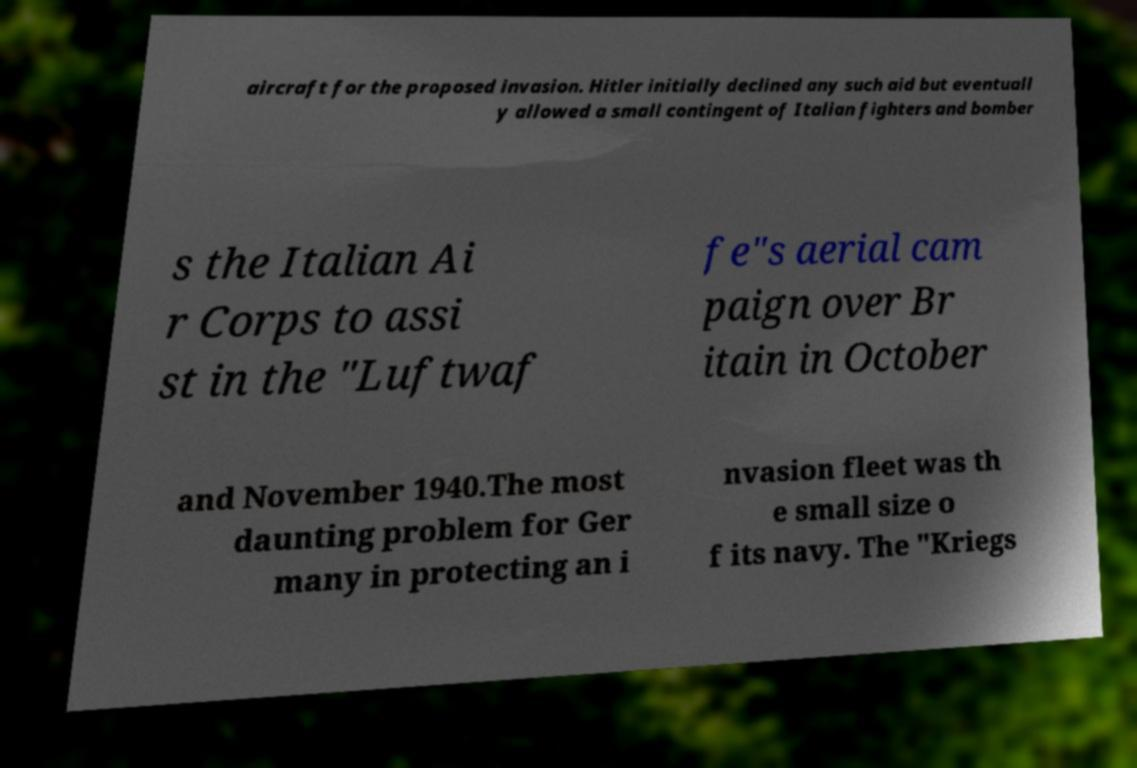What messages or text are displayed in this image? I need them in a readable, typed format. aircraft for the proposed invasion. Hitler initially declined any such aid but eventuall y allowed a small contingent of Italian fighters and bomber s the Italian Ai r Corps to assi st in the "Luftwaf fe"s aerial cam paign over Br itain in October and November 1940.The most daunting problem for Ger many in protecting an i nvasion fleet was th e small size o f its navy. The "Kriegs 